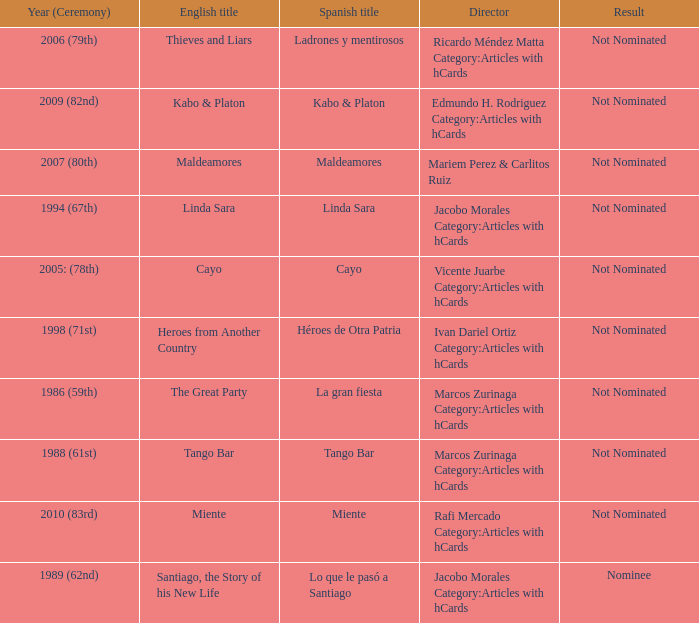What was the English title of Ladrones Y Mentirosos? Thieves and Liars. 